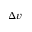Convert formula to latex. <formula><loc_0><loc_0><loc_500><loc_500>\Delta v</formula> 